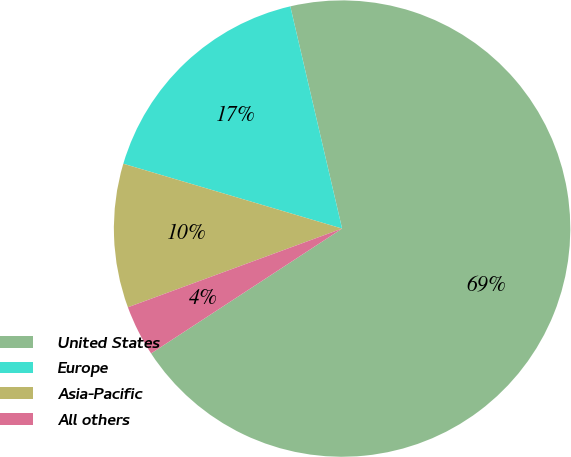<chart> <loc_0><loc_0><loc_500><loc_500><pie_chart><fcel>United States<fcel>Europe<fcel>Asia-Pacific<fcel>All others<nl><fcel>69.43%<fcel>16.77%<fcel>10.19%<fcel>3.61%<nl></chart> 